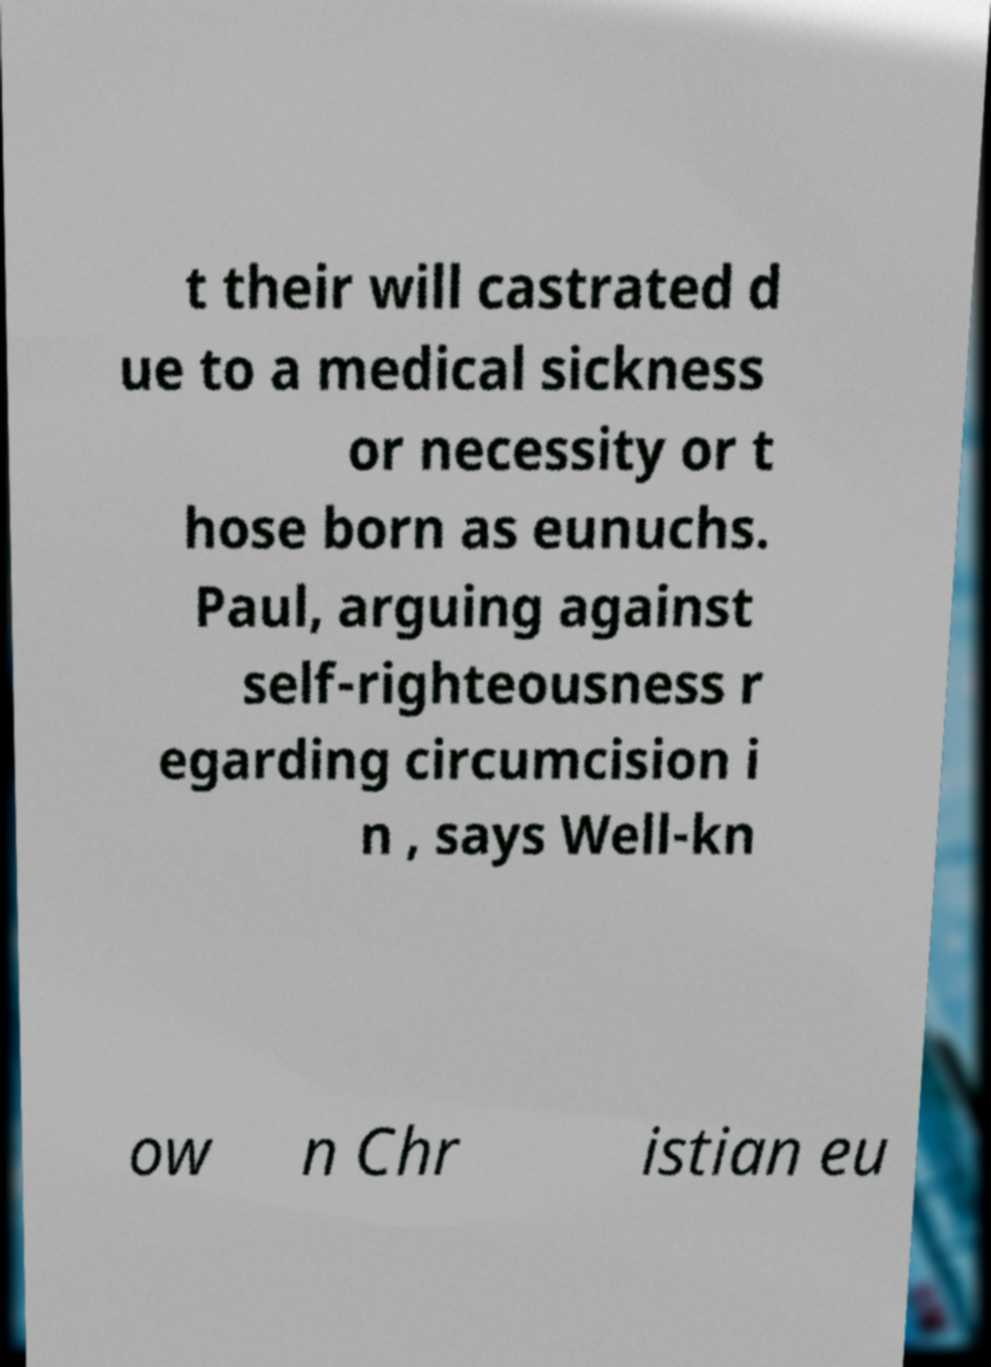I need the written content from this picture converted into text. Can you do that? t their will castrated d ue to a medical sickness or necessity or t hose born as eunuchs. Paul, arguing against self-righteousness r egarding circumcision i n , says Well-kn ow n Chr istian eu 